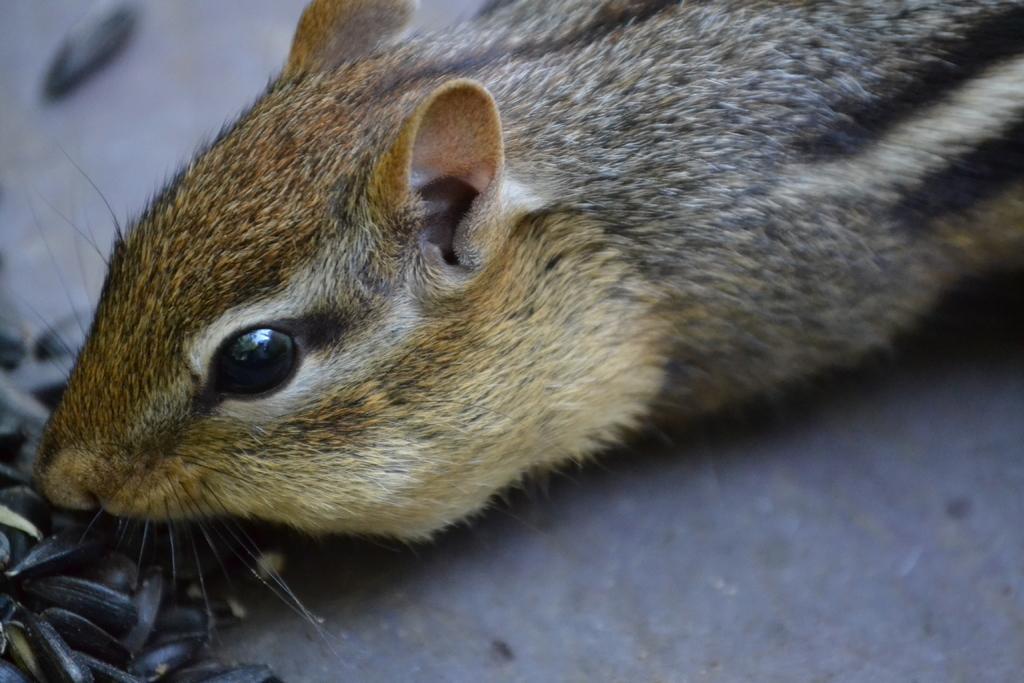Could you give a brief overview of what you see in this image? In this picture there is a squirrel in the center of the image and there are seeds in the bottom side of the image. 